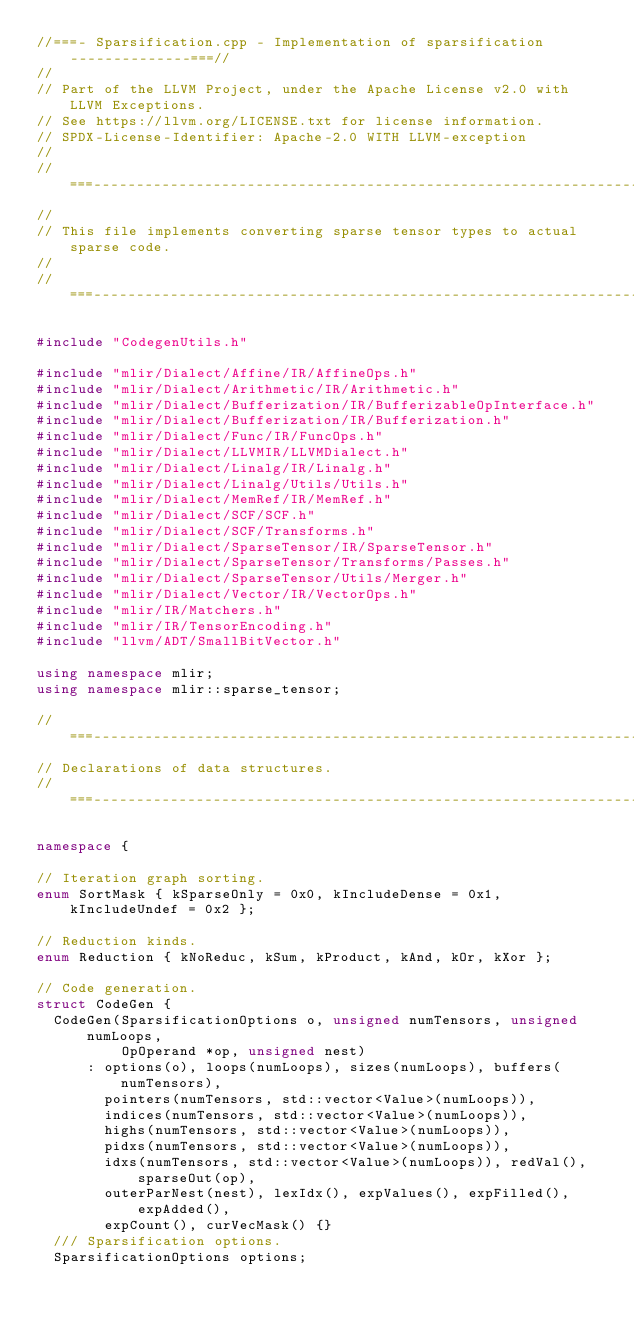Convert code to text. <code><loc_0><loc_0><loc_500><loc_500><_C++_>//===- Sparsification.cpp - Implementation of sparsification --------------===//
//
// Part of the LLVM Project, under the Apache License v2.0 with LLVM Exceptions.
// See https://llvm.org/LICENSE.txt for license information.
// SPDX-License-Identifier: Apache-2.0 WITH LLVM-exception
//
//===----------------------------------------------------------------------===//
//
// This file implements converting sparse tensor types to actual sparse code.
//
//===----------------------------------------------------------------------===//

#include "CodegenUtils.h"

#include "mlir/Dialect/Affine/IR/AffineOps.h"
#include "mlir/Dialect/Arithmetic/IR/Arithmetic.h"
#include "mlir/Dialect/Bufferization/IR/BufferizableOpInterface.h"
#include "mlir/Dialect/Bufferization/IR/Bufferization.h"
#include "mlir/Dialect/Func/IR/FuncOps.h"
#include "mlir/Dialect/LLVMIR/LLVMDialect.h"
#include "mlir/Dialect/Linalg/IR/Linalg.h"
#include "mlir/Dialect/Linalg/Utils/Utils.h"
#include "mlir/Dialect/MemRef/IR/MemRef.h"
#include "mlir/Dialect/SCF/SCF.h"
#include "mlir/Dialect/SCF/Transforms.h"
#include "mlir/Dialect/SparseTensor/IR/SparseTensor.h"
#include "mlir/Dialect/SparseTensor/Transforms/Passes.h"
#include "mlir/Dialect/SparseTensor/Utils/Merger.h"
#include "mlir/Dialect/Vector/IR/VectorOps.h"
#include "mlir/IR/Matchers.h"
#include "mlir/IR/TensorEncoding.h"
#include "llvm/ADT/SmallBitVector.h"

using namespace mlir;
using namespace mlir::sparse_tensor;

//===----------------------------------------------------------------------===//
// Declarations of data structures.
//===----------------------------------------------------------------------===//

namespace {

// Iteration graph sorting.
enum SortMask { kSparseOnly = 0x0, kIncludeDense = 0x1, kIncludeUndef = 0x2 };

// Reduction kinds.
enum Reduction { kNoReduc, kSum, kProduct, kAnd, kOr, kXor };

// Code generation.
struct CodeGen {
  CodeGen(SparsificationOptions o, unsigned numTensors, unsigned numLoops,
          OpOperand *op, unsigned nest)
      : options(o), loops(numLoops), sizes(numLoops), buffers(numTensors),
        pointers(numTensors, std::vector<Value>(numLoops)),
        indices(numTensors, std::vector<Value>(numLoops)),
        highs(numTensors, std::vector<Value>(numLoops)),
        pidxs(numTensors, std::vector<Value>(numLoops)),
        idxs(numTensors, std::vector<Value>(numLoops)), redVal(), sparseOut(op),
        outerParNest(nest), lexIdx(), expValues(), expFilled(), expAdded(),
        expCount(), curVecMask() {}
  /// Sparsification options.
  SparsificationOptions options;</code> 